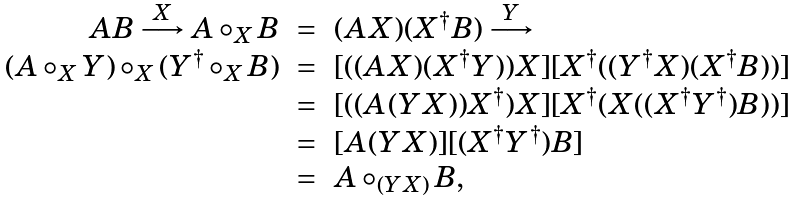Convert formula to latex. <formula><loc_0><loc_0><loc_500><loc_500>\begin{array} { r c l } A B \stackrel { X } { \longrightarrow } A \circ _ { X } B & = & ( A X ) ( X ^ { \dagger } B ) \stackrel { Y } { \longrightarrow } \\ ( A \circ _ { X } Y ) \circ _ { X } ( Y ^ { \dagger } \circ _ { X } B ) & = & [ ( ( A X ) ( X ^ { \dagger } Y ) ) X ] [ X ^ { \dagger } ( ( Y ^ { \dagger } X ) ( X ^ { \dagger } B ) ) ] \\ & = & [ ( ( A ( Y X ) ) X ^ { \dagger } ) X ] [ X ^ { \dagger } ( X ( ( X ^ { \dagger } Y ^ { \dagger } ) B ) ) ] \\ & = & [ A ( Y X ) ] [ ( X ^ { \dagger } Y ^ { \dagger } ) B ] \\ & = & A \circ _ { ( Y X ) } B , \\ \end{array}</formula> 